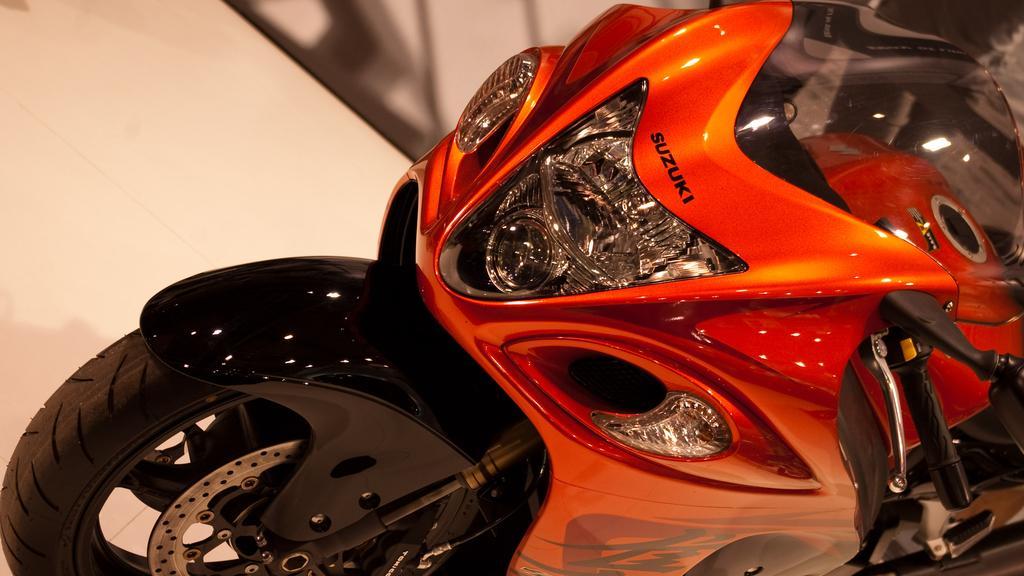Please provide a concise description of this image. In this image I can see an orange and black colour bike. Above the headlight of the bike I can see something is written. 